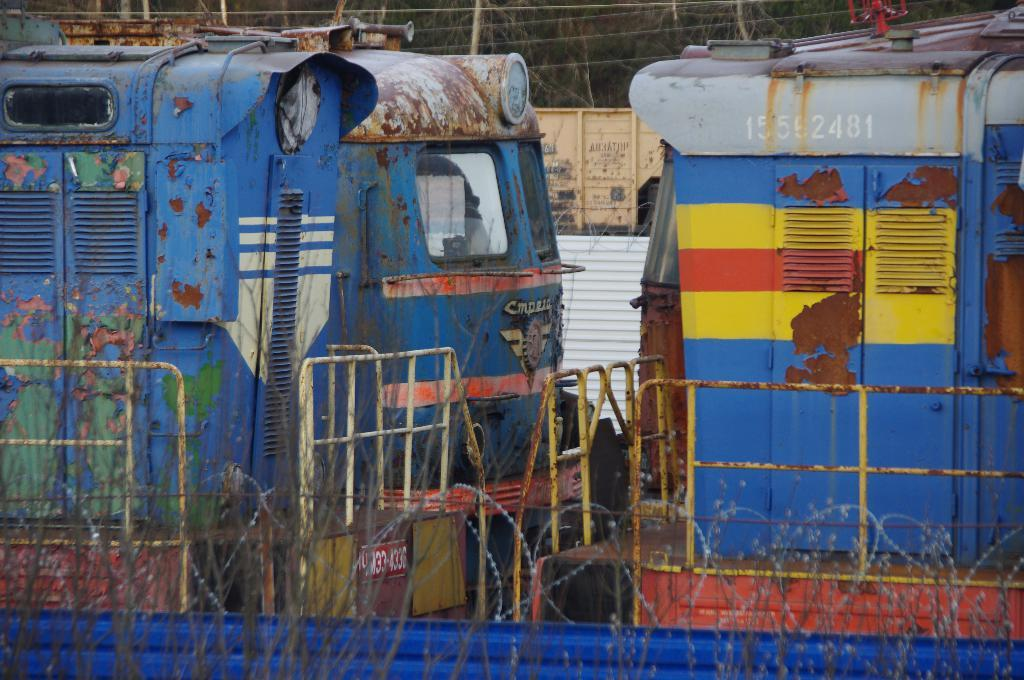How many trains are visible in the image? There are two blue color trains in the image. What is the color of the trains? The trains are blue. What can be seen in the image besides the trains? There is a fencing in the image. What is the color of the object in the background? There is a white color object in the background of the image. What news is being discussed by the trains in the image? There is no indication in the image that the trains are discussing any news. Can you see the heart rate of the trains in the image? Trains do not have heart rates, so this cannot be observed in the image. 